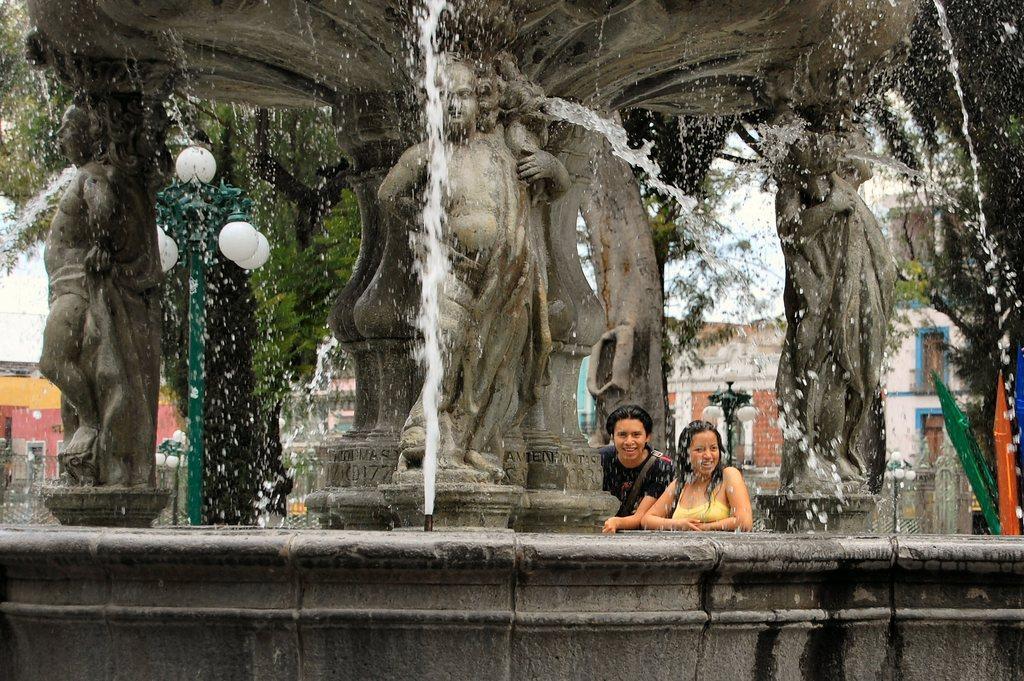How would you summarize this image in a sentence or two? In this picture I can see few statues, water and couple humans standing. I can see pole lights, trees and buildings in the back. 